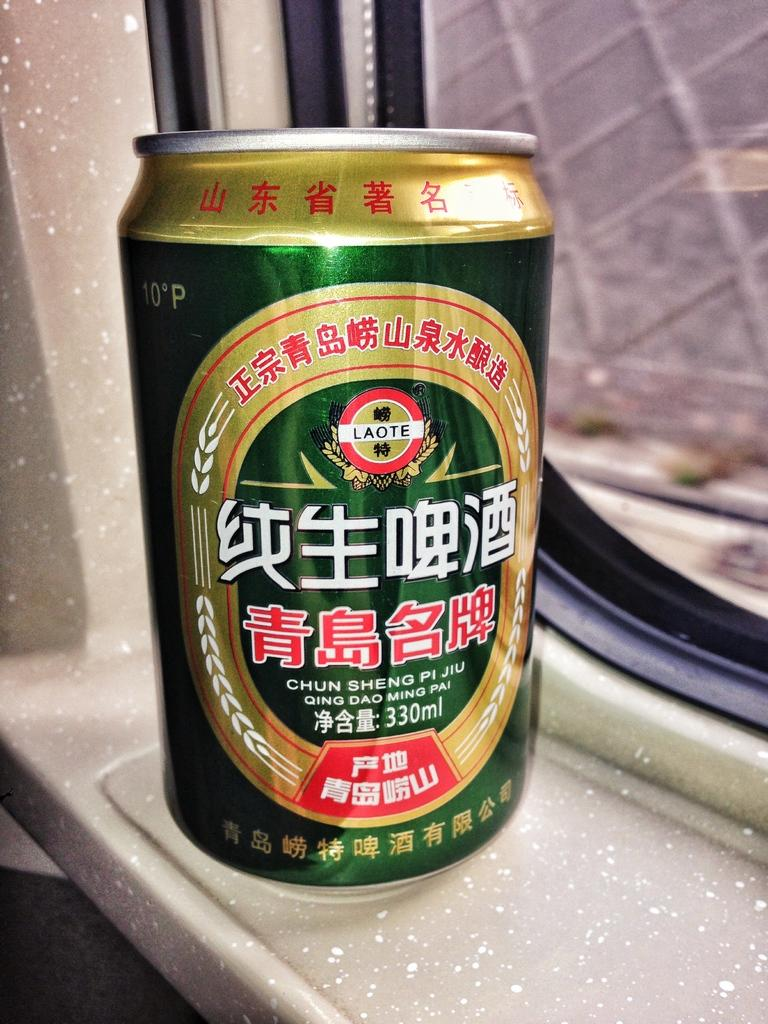<image>
Write a terse but informative summary of the picture. A green can says Chun Sheng Pi Jiu and is sitting in a window sill. 